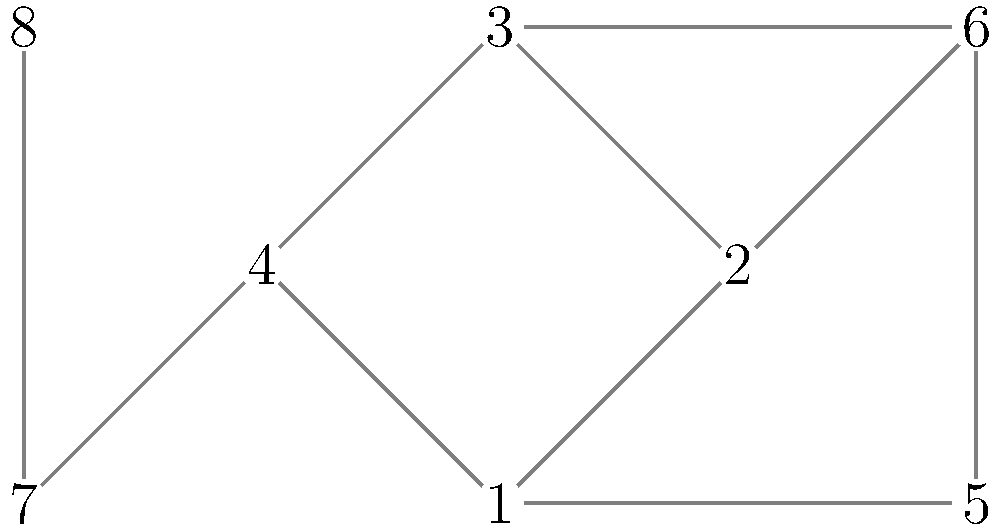In your novel, you've created a graph representing the relationships between characters. Each vertex represents a character, and each edge represents a significant interaction or relationship between two characters. What is the minimum number of characters (vertices) that need to be removed to disconnect the graph into two or more components? To solve this problem, we need to find the vertex connectivity of the graph. The vertex connectivity is the minimum number of vertices that need to be removed to disconnect the graph. Let's approach this step-by-step:

1. First, observe that the graph is connected, as there is a path between any two vertices.

2. Look for potential cut vertices (articulation points). These are vertices that, if removed, would disconnect the graph.

3. Vertex 1 is not a cut vertex, as removing it still leaves the graph connected.

4. Vertex 4 is not a cut vertex for the same reason.

5. Vertices 2, 3, and 5 are not cut vertices either, as their removal doesn't disconnect the graph.

6. However, removing both vertices 1 and 4 disconnects the graph into three components: {2,3,5}, {6,7}, and {8}.

7. There is no single vertex whose removal disconnects the graph, so the vertex connectivity is at least 2.

8. We've found a set of 2 vertices (1 and 4) whose removal disconnects the graph, and there is no smaller set that achieves this.

Therefore, the vertex connectivity of this graph is 2, meaning at least 2 characters need to be removed to disconnect the graph.
Answer: 2 